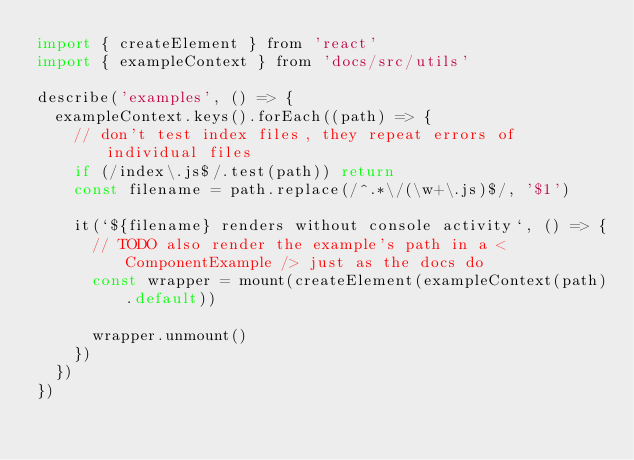<code> <loc_0><loc_0><loc_500><loc_500><_JavaScript_>import { createElement } from 'react'
import { exampleContext } from 'docs/src/utils'

describe('examples', () => {
  exampleContext.keys().forEach((path) => {
    // don't test index files, they repeat errors of individual files
    if (/index\.js$/.test(path)) return
    const filename = path.replace(/^.*\/(\w+\.js)$/, '$1')

    it(`${filename} renders without console activity`, () => {
      // TODO also render the example's path in a <ComponentExample /> just as the docs do
      const wrapper = mount(createElement(exampleContext(path).default))

      wrapper.unmount()
    })
  })
})
</code> 